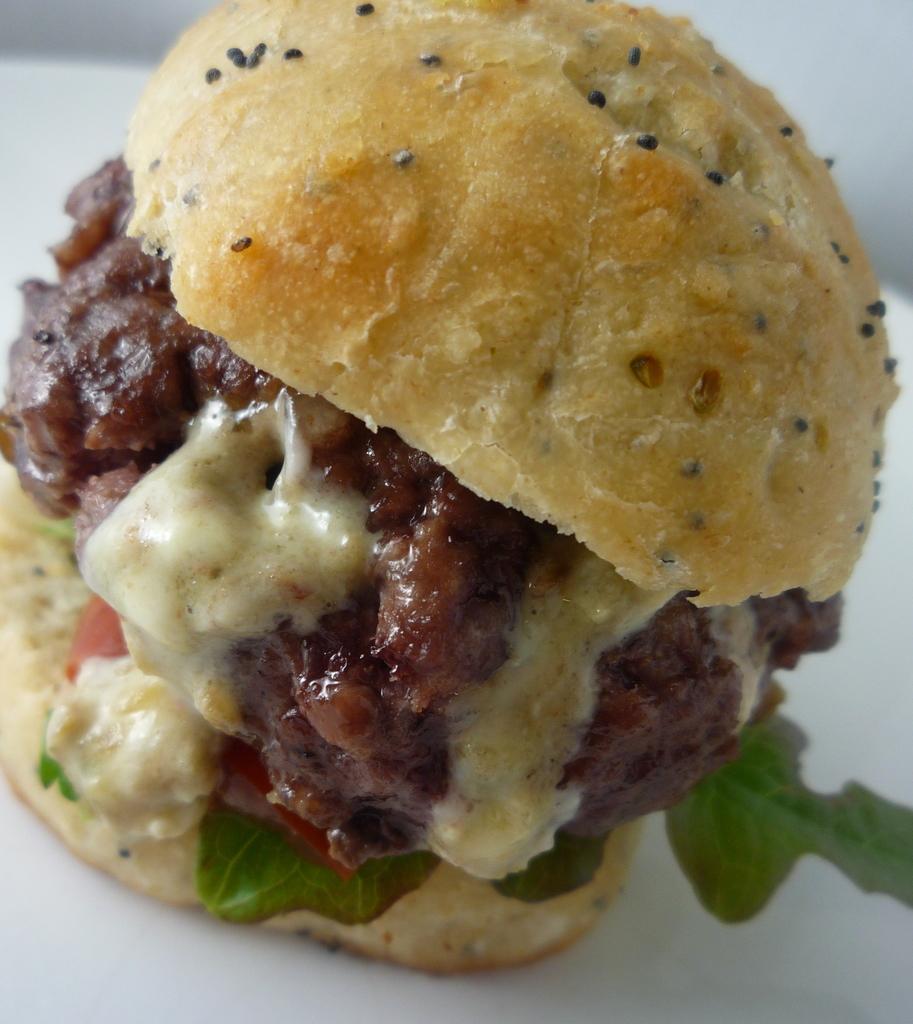Please provide a concise description of this image. In this image, I can see a burger. This burger is made of bread, patty, cheese, spinach and few other ingredients. The background looks white in color. 